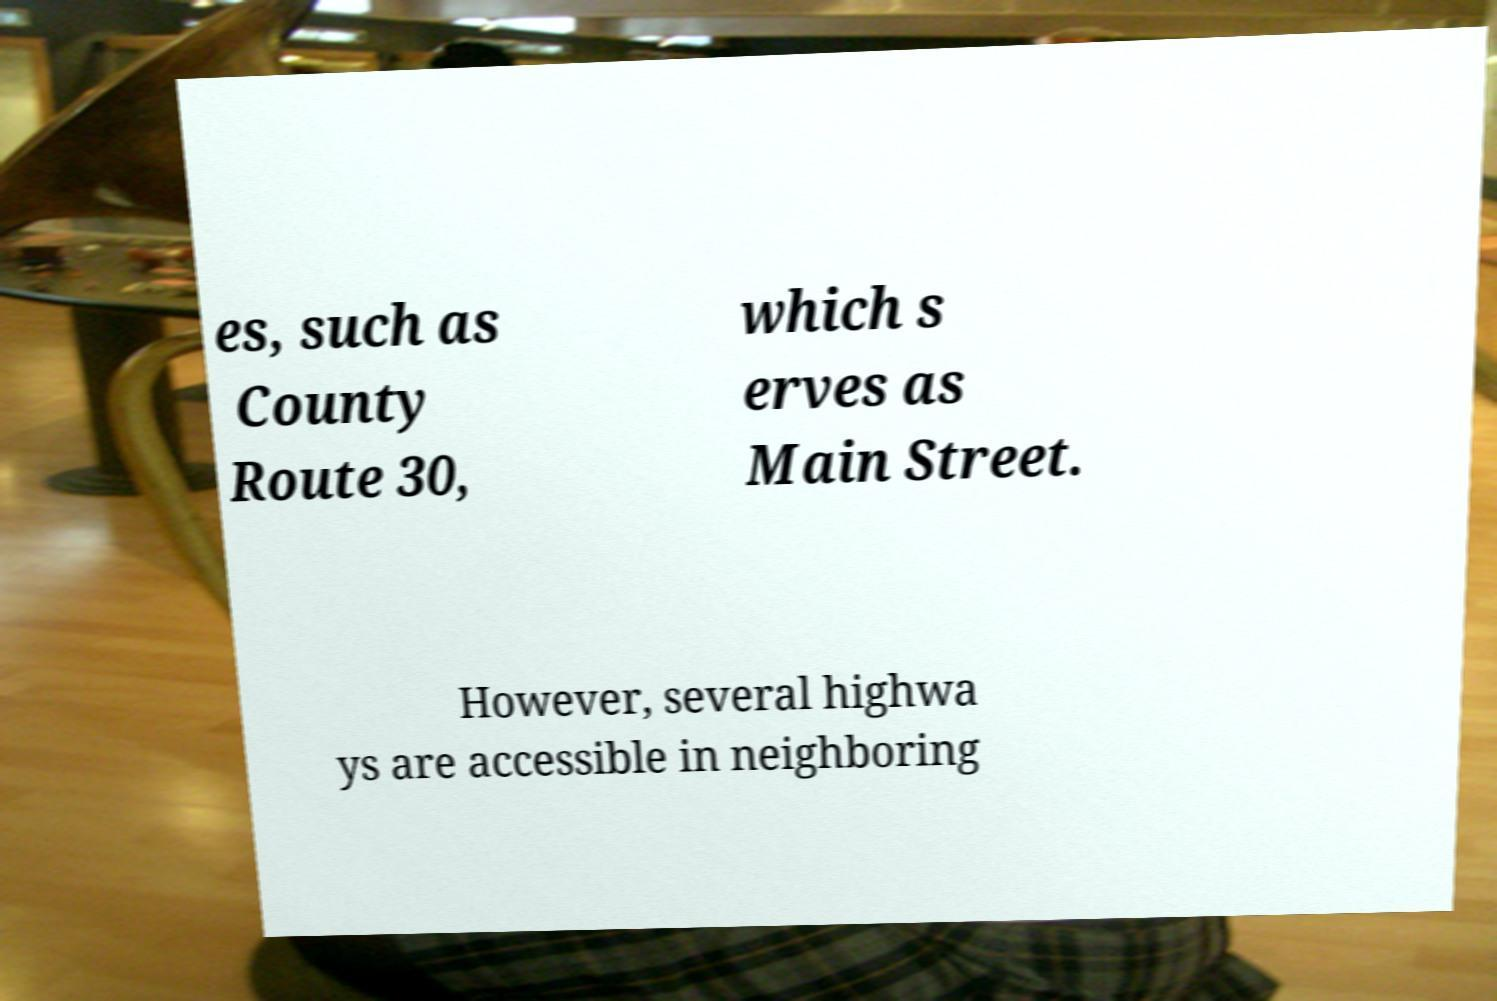Please identify and transcribe the text found in this image. es, such as County Route 30, which s erves as Main Street. However, several highwa ys are accessible in neighboring 